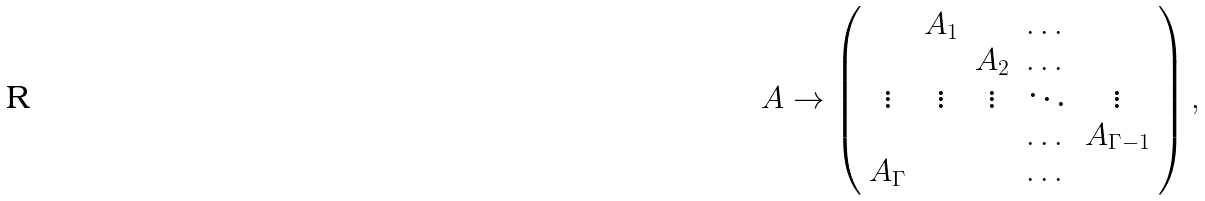<formula> <loc_0><loc_0><loc_500><loc_500>A \rightarrow \left ( \begin{array} { c c c c c } & A _ { 1 } & & \dots & \\ & & A _ { 2 } & \dots & \\ \vdots & \vdots & \vdots & \ddots & \vdots \\ & & & \dots & A _ { \Gamma - 1 } \\ A _ { \Gamma } & & & \dots & \end{array} \right ) ,</formula> 